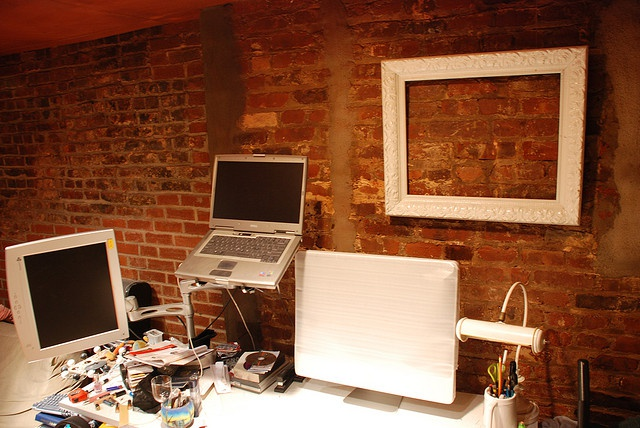Describe the objects in this image and their specific colors. I can see laptop in maroon, black, gray, and tan tones, tv in maroon, black, and tan tones, cup in maroon, ivory, and tan tones, and cup in maroon, khaki, darkgray, and beige tones in this image. 